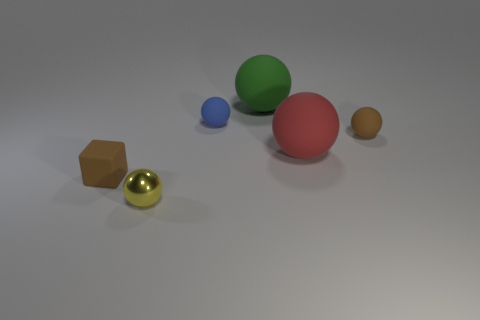Add 1 large matte things. How many objects exist? 7 Subtract all small brown rubber balls. How many balls are left? 4 Subtract all brown spheres. How many spheres are left? 4 Subtract 1 yellow balls. How many objects are left? 5 Subtract all blocks. How many objects are left? 5 Subtract 1 cubes. How many cubes are left? 0 Subtract all green blocks. Subtract all cyan cylinders. How many blocks are left? 1 Subtract all blue cubes. How many gray balls are left? 0 Subtract all small green rubber cubes. Subtract all brown things. How many objects are left? 4 Add 6 small yellow metal spheres. How many small yellow metal spheres are left? 7 